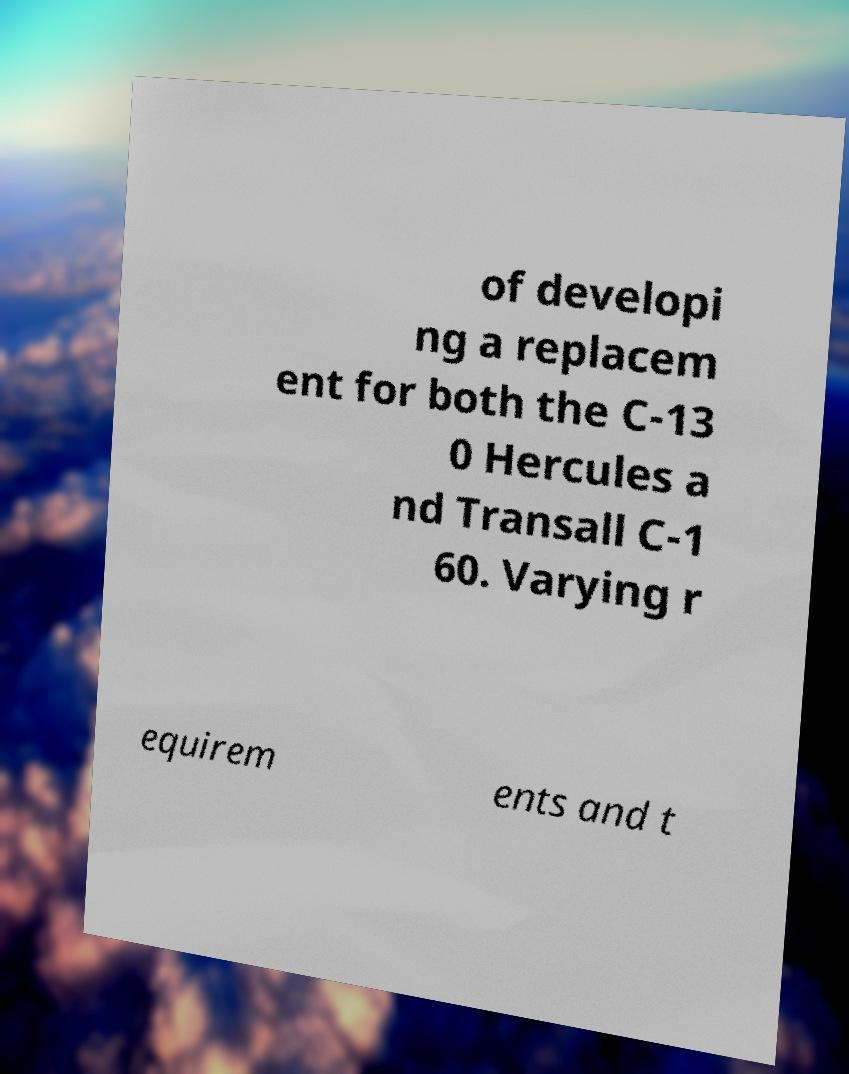Please read and relay the text visible in this image. What does it say? of developi ng a replacem ent for both the C-13 0 Hercules a nd Transall C-1 60. Varying r equirem ents and t 